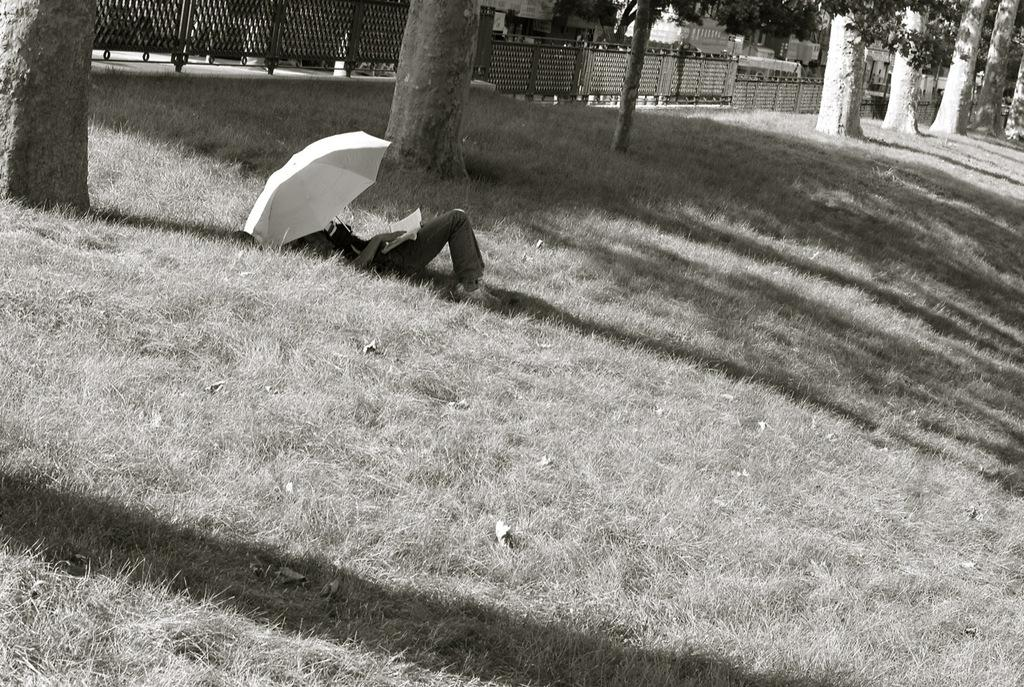What is the person in the image doing? The person is lying on the ground in the image. What is the person holding while lying on the ground? The person is holding a book. What can be seen in the image besides the person and the book? There is an umbrella, buildings, trees, grass, and a fence visible in the image. What type of jelly can be seen in the jar on the person's left side in the image? There is no jar or jelly present in the image. 